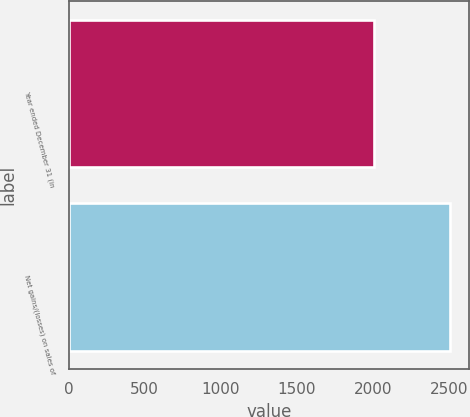Convert chart to OTSL. <chart><loc_0><loc_0><loc_500><loc_500><bar_chart><fcel>Year ended December 31 (in<fcel>Net gains/(losses) on sales of<nl><fcel>2008<fcel>2508<nl></chart> 